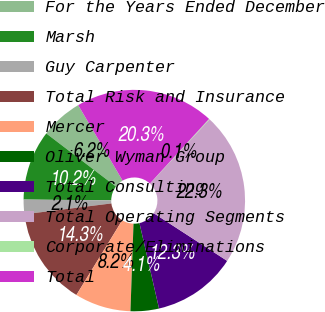Convert chart to OTSL. <chart><loc_0><loc_0><loc_500><loc_500><pie_chart><fcel>For the Years Ended December<fcel>Marsh<fcel>Guy Carpenter<fcel>Total Risk and Insurance<fcel>Mercer<fcel>Oliver Wyman Group<fcel>Total Consulting<fcel>Total Operating Segments<fcel>Corporate/Eliminations<fcel>Total<nl><fcel>6.17%<fcel>10.22%<fcel>2.12%<fcel>14.27%<fcel>8.2%<fcel>4.14%<fcel>12.25%<fcel>22.28%<fcel>0.09%<fcel>20.25%<nl></chart> 